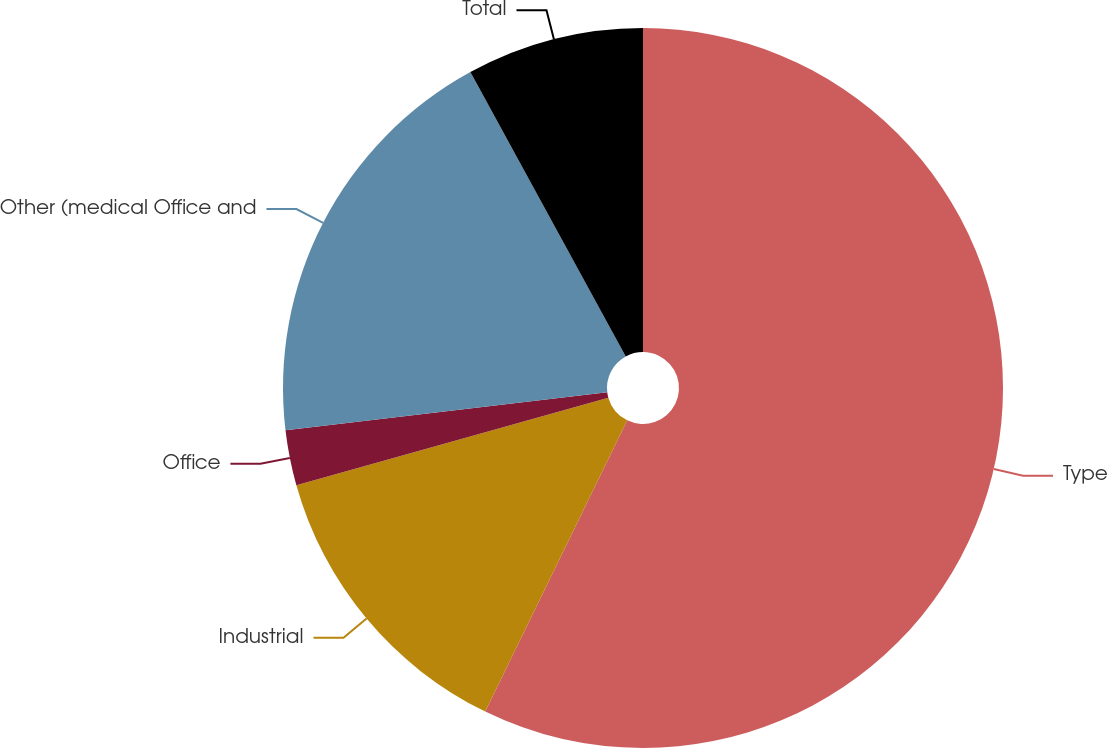Convert chart to OTSL. <chart><loc_0><loc_0><loc_500><loc_500><pie_chart><fcel>Type<fcel>Industrial<fcel>Office<fcel>Other (medical Office and<fcel>Total<nl><fcel>57.22%<fcel>13.43%<fcel>2.48%<fcel>18.91%<fcel>7.96%<nl></chart> 